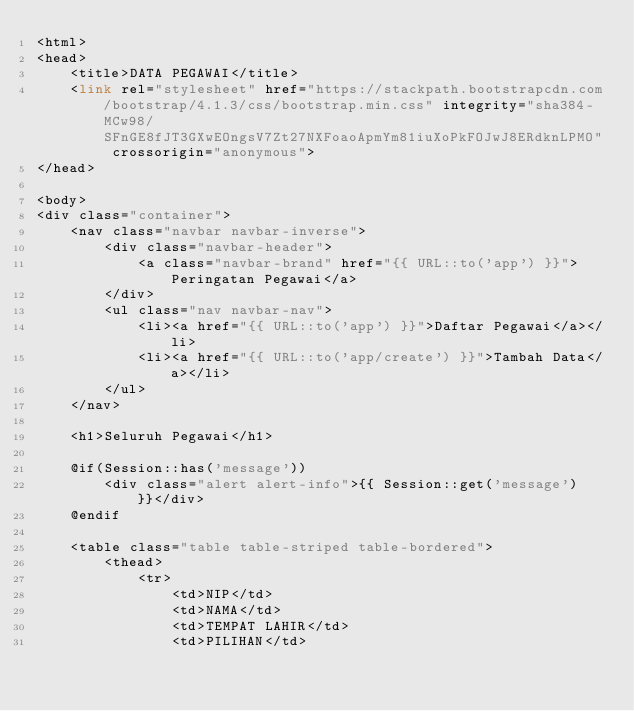<code> <loc_0><loc_0><loc_500><loc_500><_PHP_><html>
<head>
    <title>DATA PEGAWAI</title>
    <link rel="stylesheet" href="https://stackpath.bootstrapcdn.com/bootstrap/4.1.3/css/bootstrap.min.css" integrity="sha384-MCw98/SFnGE8fJT3GXwEOngsV7Zt27NXFoaoApmYm81iuXoPkFOJwJ8ERdknLPMO" crossorigin="anonymous">
</head>

<body>
<div class="container">
    <nav class="navbar navbar-inverse">
        <div class="navbar-header">
            <a class="navbar-brand" href="{{ URL::to('app') }}">Peringatan Pegawai</a>
        </div>
        <ul class="nav navbar-nav">
            <li><a href="{{ URL::to('app') }}">Daftar Pegawai</a></li>
            <li><a href="{{ URL::to('app/create') }}">Tambah Data</a></li>
        </ul>
    </nav>

    <h1>Seluruh Pegawai</h1>

    @if(Session::has('message'))
        <div class="alert alert-info">{{ Session::get('message') }}</div>
    @endif

    <table class="table table-striped table-bordered">
        <thead>
            <tr>
                <td>NIP</td>
                <td>NAMA</td>
                <td>TEMPAT LAHIR</td>
                <td>PILIHAN</td></code> 